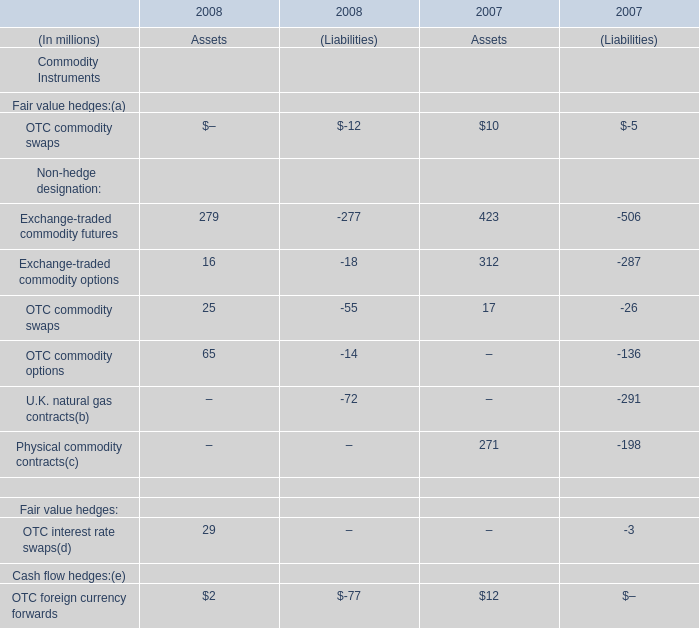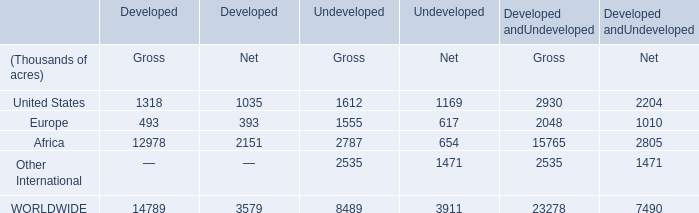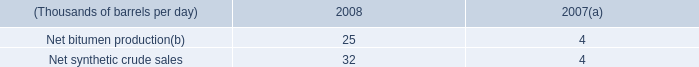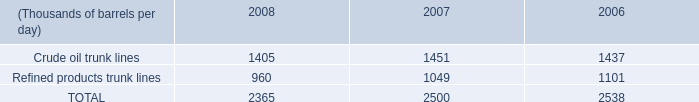What is the sum of United States of Undeveloped Gross, Crude oil trunk lines of 2008, and Other International of Undeveloped Net ? 
Computations: ((1612.0 + 1405.0) + 1471.0)
Answer: 4488.0. 